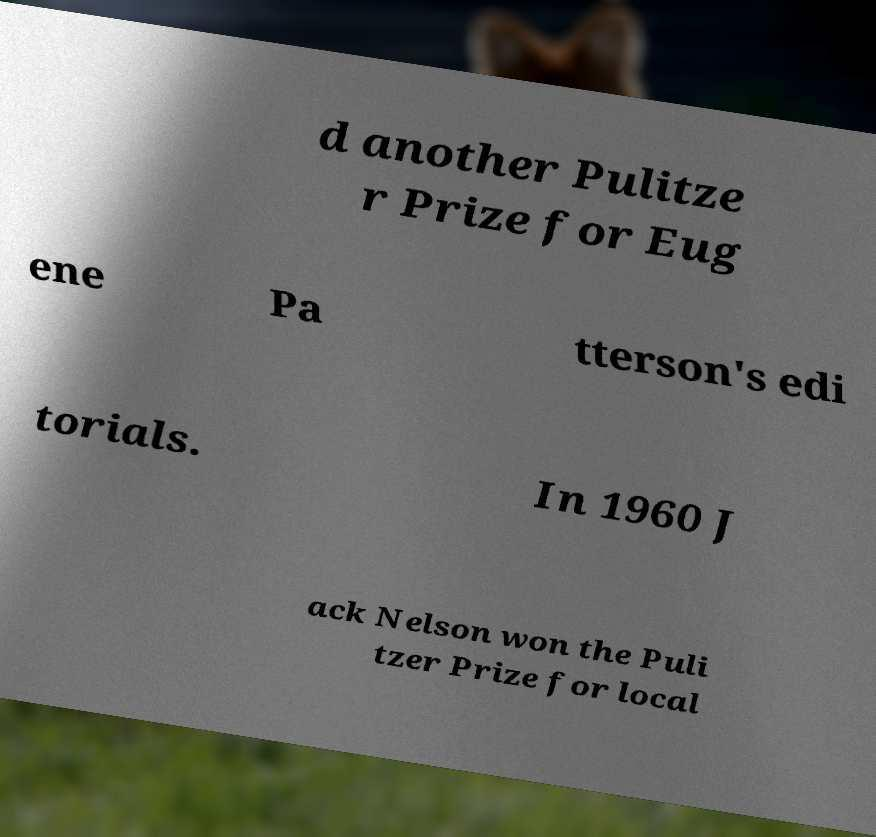Could you extract and type out the text from this image? d another Pulitze r Prize for Eug ene Pa tterson's edi torials. In 1960 J ack Nelson won the Puli tzer Prize for local 